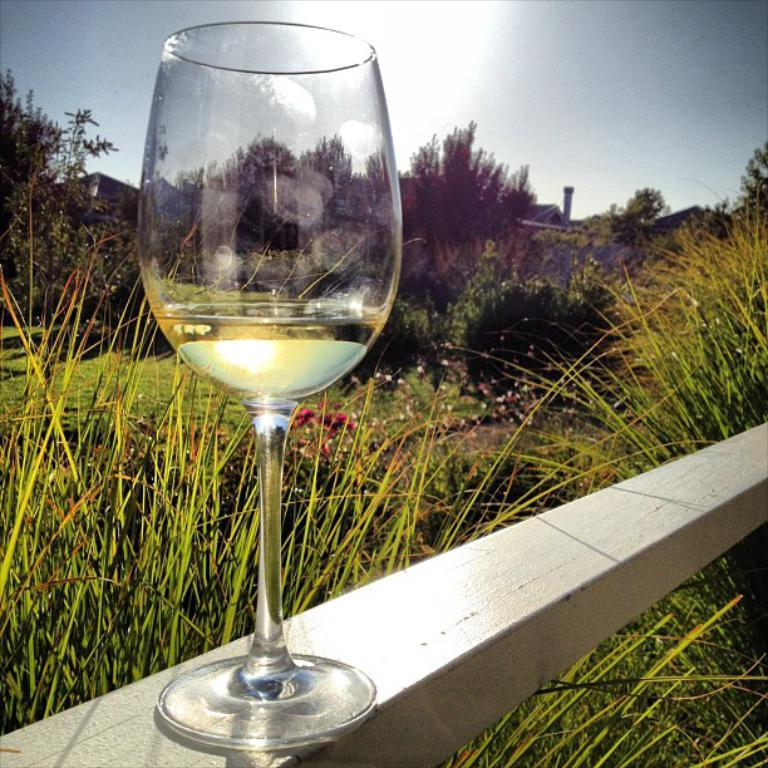What object can be seen in the image? There is a glass in the image. What can be seen in the background of the image? There are plants, grass, trees, a building, and the sky visible in the background of the image. What type of advice is being given in the image? There is no indication of any advice being given in the image; it primarily features a glass and various background elements. 